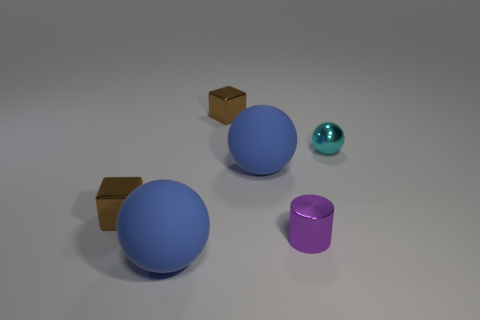What material is the cyan ball that is the same size as the purple shiny cylinder?
Make the answer very short. Metal. What number of small objects are yellow metallic cubes or metallic spheres?
Ensure brevity in your answer.  1. Are there any small cyan rubber balls?
Your answer should be very brief. No. There is a purple cylinder that is made of the same material as the tiny cyan sphere; what size is it?
Your response must be concise. Small. Does the cyan thing have the same material as the small cylinder?
Your answer should be compact. Yes. What number of other things are the same material as the cyan thing?
Provide a short and direct response. 3. How many metallic things are both to the right of the purple thing and behind the small shiny sphere?
Your response must be concise. 0. What is the color of the metal cylinder?
Make the answer very short. Purple. There is a small object in front of the block in front of the small shiny ball; what shape is it?
Provide a short and direct response. Cylinder. The cyan object that is the same material as the purple object is what shape?
Your response must be concise. Sphere. 